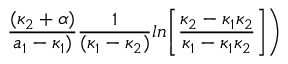Convert formula to latex. <formula><loc_0><loc_0><loc_500><loc_500>{ \frac { ( \kappa _ { 2 } + \alpha ) } { a _ { 1 } - \kappa _ { 1 } ) } } { \frac { 1 } { ( \kappa _ { 1 } - \kappa _ { 2 } ) } } \ln \Big [ { \frac { \kappa _ { 2 } - \kappa _ { 1 } \kappa _ { 2 } } { \kappa _ { 1 } - \kappa _ { 1 } \kappa _ { 2 } } } \Big ] \Big )</formula> 